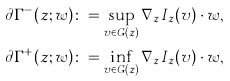<formula> <loc_0><loc_0><loc_500><loc_500>& \partial \Gamma ^ { - } ( z ; w ) \colon = \sup _ { v \in G ( z ) } \nabla _ { z } I _ { z } ( v ) \cdot w , \\ & \partial \Gamma ^ { + } ( z ; w ) \colon = \inf _ { v \in G ( z ) } \nabla _ { z } I _ { z } ( v ) \cdot w ,</formula> 